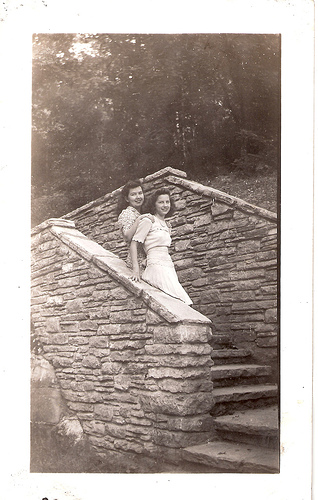<image>
Is there a woman in the dress? No. The woman is not contained within the dress. These objects have a different spatial relationship. 